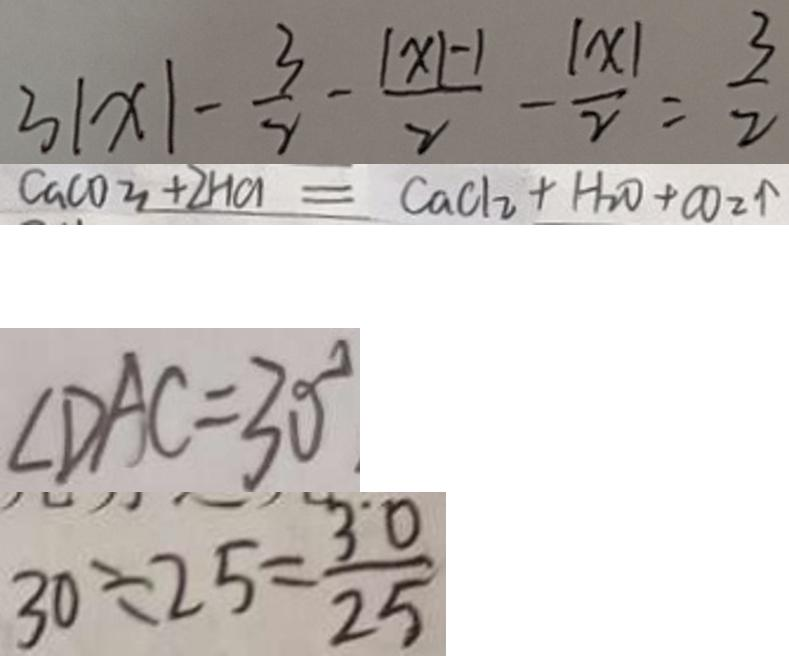<formula> <loc_0><loc_0><loc_500><loc_500>3 \vert x \vert - \frac { 3 } { 2 } - \frac { \vert x \vert - 1 } { 2 } - \frac { \vert x \vert } { 2 } = \frac { 3 } { 2 } 
 C a C O _ { 3 } + 2 H C l = C a C l _ { 2 } + H _ { 2 } O + C O _ { 2 } \uparrow 
 \angle D A C = 3 0 ^ { \circ } 
 3 0 \div 2 5 = \frac { 3 0 } { 2 5 }</formula> 